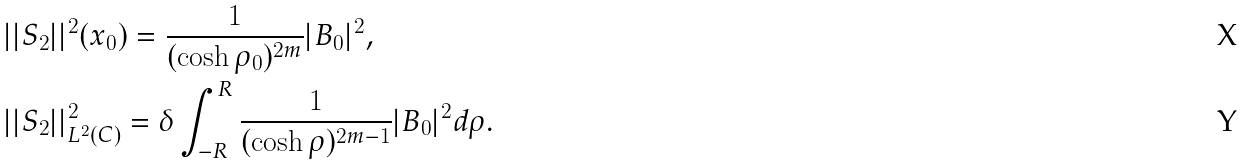<formula> <loc_0><loc_0><loc_500><loc_500>& | | S _ { 2 } | | ^ { 2 } ( x _ { 0 } ) = \frac { 1 } { ( \cosh \rho _ { 0 } ) ^ { 2 m } } | B _ { 0 } | ^ { 2 } , \\ & | | S _ { 2 } | | ^ { 2 } _ { L ^ { 2 } ( C ) } = \delta \int ^ { R } _ { - R } \frac { 1 } { ( \cosh \rho ) ^ { 2 m - 1 } } | B _ { 0 } | ^ { 2 } d \rho .</formula> 